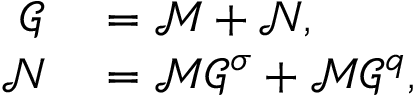<formula> <loc_0><loc_0><loc_500><loc_500>\begin{array} { r l } { \mathcal { G } } & = \mathcal { M } + \mathcal { N } , } \\ { \mathcal { N } } & = \mathcal { M } \mathcal { G } ^ { \sigma } + \mathcal { M } \mathcal { G } ^ { q } , } \end{array}</formula> 